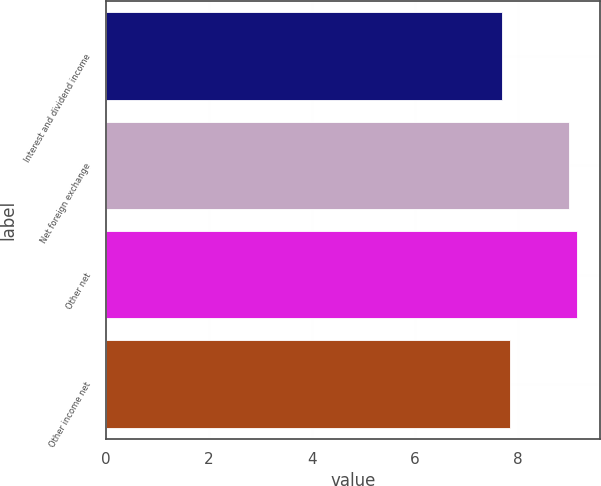<chart> <loc_0><loc_0><loc_500><loc_500><bar_chart><fcel>Interest and dividend income<fcel>Net foreign exchange<fcel>Other net<fcel>Other income net<nl><fcel>7.7<fcel>9<fcel>9.14<fcel>7.84<nl></chart> 